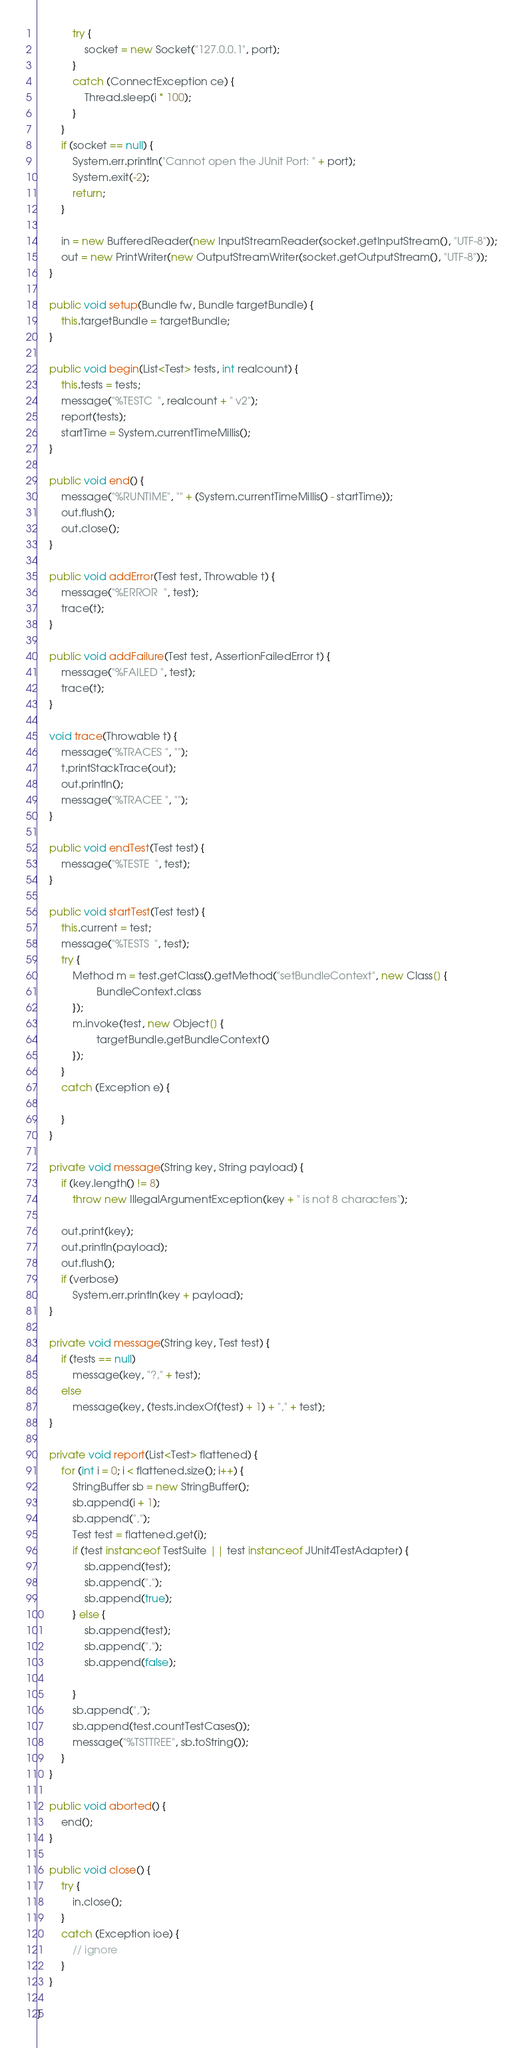Convert code to text. <code><loc_0><loc_0><loc_500><loc_500><_Java_>			try {
				socket = new Socket("127.0.0.1", port);
			}
			catch (ConnectException ce) {
				Thread.sleep(i * 100);
			}
		}
		if (socket == null) {
			System.err.println("Cannot open the JUnit Port: " + port);
			System.exit(-2);
			return;
		}

		in = new BufferedReader(new InputStreamReader(socket.getInputStream(), "UTF-8"));
		out = new PrintWriter(new OutputStreamWriter(socket.getOutputStream(), "UTF-8"));
	}

	public void setup(Bundle fw, Bundle targetBundle) {
		this.targetBundle = targetBundle;
	}

	public void begin(List<Test> tests, int realcount) {
		this.tests = tests;
		message("%TESTC  ", realcount + " v2");
		report(tests);
		startTime = System.currentTimeMillis();
	}

	public void end() {
		message("%RUNTIME", "" + (System.currentTimeMillis() - startTime));
		out.flush();
		out.close();
	}

	public void addError(Test test, Throwable t) {
		message("%ERROR  ", test);
		trace(t);
	}

	public void addFailure(Test test, AssertionFailedError t) {
		message("%FAILED ", test);
		trace(t);
	}

	void trace(Throwable t) {
		message("%TRACES ", "");
		t.printStackTrace(out);
		out.println();
		message("%TRACEE ", "");
	}

	public void endTest(Test test) {
		message("%TESTE  ", test);
	}

	public void startTest(Test test) {
		this.current = test;
		message("%TESTS  ", test);
		try {
			Method m = test.getClass().getMethod("setBundleContext", new Class[] {
					BundleContext.class
			});
			m.invoke(test, new Object[] {
					targetBundle.getBundleContext()
			});
		}
		catch (Exception e) {

		}
	}

	private void message(String key, String payload) {
		if (key.length() != 8)
			throw new IllegalArgumentException(key + " is not 8 characters");

		out.print(key);
		out.println(payload);
		out.flush();
		if (verbose)
			System.err.println(key + payload);
	}

	private void message(String key, Test test) {
		if (tests == null)
			message(key, "?," + test);
		else
			message(key, (tests.indexOf(test) + 1) + "," + test);
	}

	private void report(List<Test> flattened) {
		for (int i = 0; i < flattened.size(); i++) {
			StringBuffer sb = new StringBuffer();
			sb.append(i + 1);
			sb.append(",");
			Test test = flattened.get(i);
			if (test instanceof TestSuite || test instanceof JUnit4TestAdapter) {
				sb.append(test);
				sb.append(",");
				sb.append(true);
			} else {
				sb.append(test);
				sb.append(",");
				sb.append(false);

			}
			sb.append(",");
			sb.append(test.countTestCases());
			message("%TSTTREE", sb.toString());
		}
	}

	public void aborted() {
		end();
	}

	public void close() {
		try {
			in.close();
		}
		catch (Exception ioe) {
			// ignore
		}
	}

}
</code> 